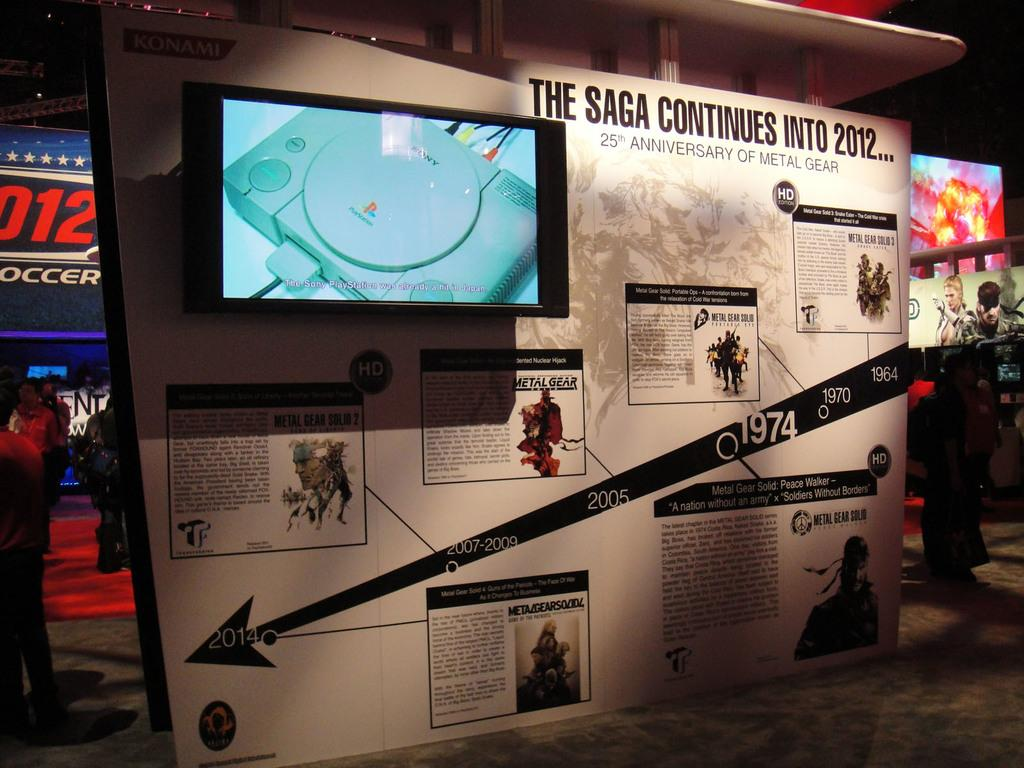<image>
Provide a brief description of the given image. Exhibit feature in a museum,that says the SAGA continues, 25th anniversary of metal gear solid. 